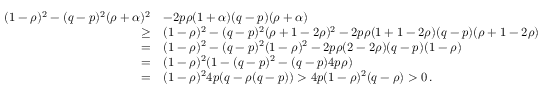<formula> <loc_0><loc_0><loc_500><loc_500>\begin{array} { r l } { ( 1 - \rho ) ^ { 2 } - ( q - p ) ^ { 2 } ( \rho + \alpha ) ^ { 2 } } & { - 2 p \rho ( 1 + \alpha ) ( q - p ) ( \rho + \alpha ) } \\ { \geq } & { ( 1 - \rho ) ^ { 2 } - ( q - p ) ^ { 2 } ( \rho + 1 - 2 \rho ) ^ { 2 } - 2 p \rho ( 1 + 1 - 2 \rho ) ( q - p ) ( \rho + 1 - 2 \rho ) } \\ { = } & { ( 1 - \rho ) ^ { 2 } - ( q - p ) ^ { 2 } ( 1 - \rho ) ^ { 2 } - 2 p \rho ( 2 - 2 \rho ) ( q - p ) ( 1 - \rho ) } \\ { = } & { ( 1 - \rho ) ^ { 2 } ( 1 - ( q - p ) ^ { 2 } - ( q - p ) 4 p \rho ) } \\ { = } & { ( 1 - \rho ) ^ { 2 } 4 p ( q - \rho ( q - p ) ) > 4 p ( 1 - \rho ) ^ { 2 } ( q - \rho ) > 0 \, . } \end{array}</formula> 